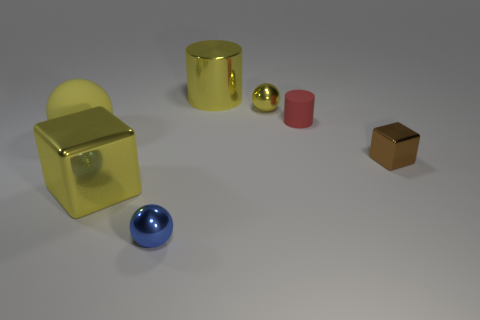Is the tiny brown cube made of the same material as the yellow sphere in front of the rubber cylinder?
Ensure brevity in your answer.  No. Is there anything else that has the same color as the big rubber thing?
Your response must be concise. Yes. How many objects are cylinders that are to the left of the tiny yellow ball or balls that are in front of the yellow block?
Your answer should be very brief. 2. The large yellow thing that is behind the large cube and right of the big yellow ball has what shape?
Your answer should be very brief. Cylinder. There is a yellow ball behind the red matte cylinder; how many large matte objects are right of it?
Provide a short and direct response. 0. What number of things are blocks that are right of the red matte object or red objects?
Give a very brief answer. 2. There is a metallic sphere in front of the tiny cylinder; what size is it?
Give a very brief answer. Small. What is the material of the big cylinder?
Your answer should be very brief. Metal. There is a thing that is to the left of the large yellow metallic cube that is in front of the small red cylinder; what is its shape?
Provide a succinct answer. Sphere. What number of other objects are there of the same shape as the yellow matte thing?
Your answer should be very brief. 2. 